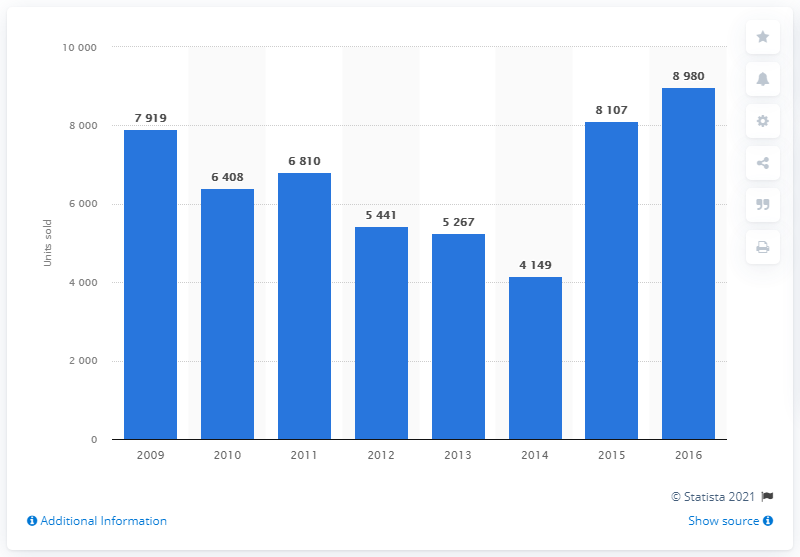Specify some key components in this picture. In France between 2015 and 2016, Smart sold a total of 8,107 cars. 